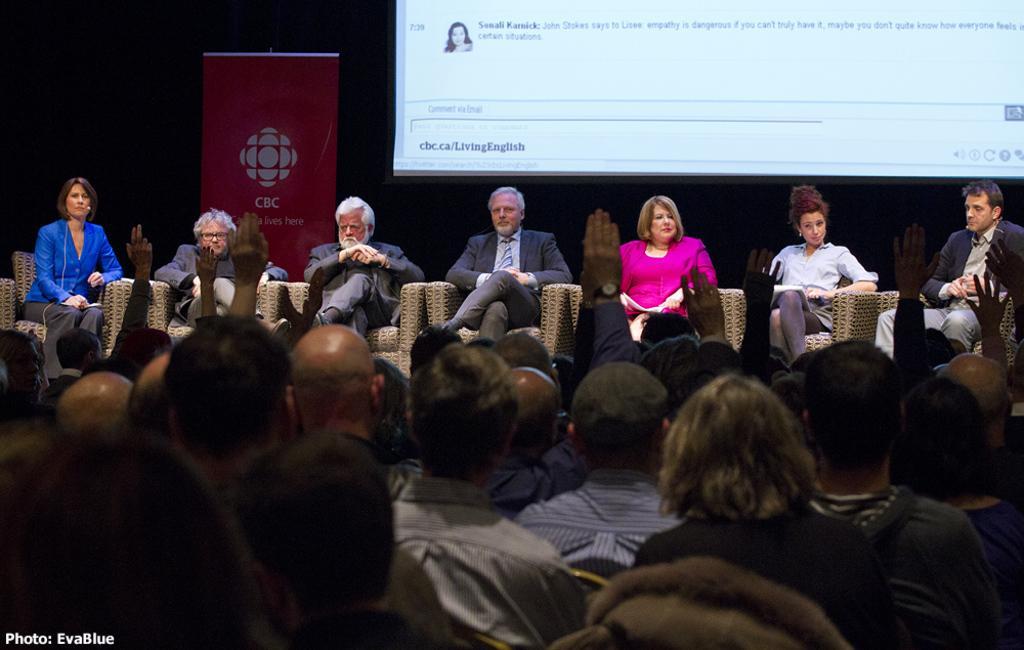Could you give a brief overview of what you see in this image? As we can see in the image there are few people here and there, chairs and a banner. 